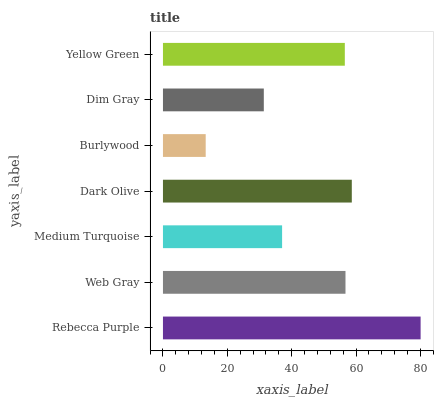Is Burlywood the minimum?
Answer yes or no. Yes. Is Rebecca Purple the maximum?
Answer yes or no. Yes. Is Web Gray the minimum?
Answer yes or no. No. Is Web Gray the maximum?
Answer yes or no. No. Is Rebecca Purple greater than Web Gray?
Answer yes or no. Yes. Is Web Gray less than Rebecca Purple?
Answer yes or no. Yes. Is Web Gray greater than Rebecca Purple?
Answer yes or no. No. Is Rebecca Purple less than Web Gray?
Answer yes or no. No. Is Yellow Green the high median?
Answer yes or no. Yes. Is Yellow Green the low median?
Answer yes or no. Yes. Is Burlywood the high median?
Answer yes or no. No. Is Dark Olive the low median?
Answer yes or no. No. 